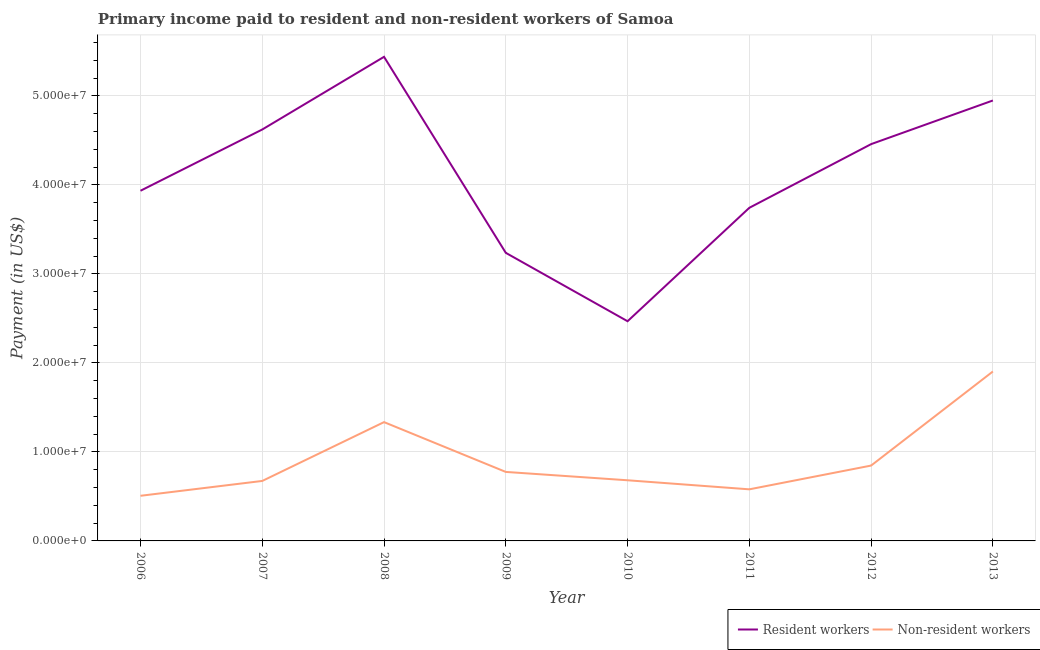What is the payment made to non-resident workers in 2013?
Make the answer very short. 1.90e+07. Across all years, what is the maximum payment made to non-resident workers?
Ensure brevity in your answer.  1.90e+07. Across all years, what is the minimum payment made to resident workers?
Provide a short and direct response. 2.47e+07. What is the total payment made to resident workers in the graph?
Your answer should be very brief. 3.28e+08. What is the difference between the payment made to non-resident workers in 2010 and that in 2012?
Provide a short and direct response. -1.65e+06. What is the difference between the payment made to resident workers in 2007 and the payment made to non-resident workers in 2008?
Your answer should be compact. 3.29e+07. What is the average payment made to resident workers per year?
Provide a succinct answer. 4.11e+07. In the year 2010, what is the difference between the payment made to non-resident workers and payment made to resident workers?
Ensure brevity in your answer.  -1.79e+07. In how many years, is the payment made to resident workers greater than 38000000 US$?
Offer a very short reply. 5. What is the ratio of the payment made to resident workers in 2012 to that in 2013?
Your answer should be very brief. 0.9. Is the difference between the payment made to resident workers in 2006 and 2007 greater than the difference between the payment made to non-resident workers in 2006 and 2007?
Make the answer very short. No. What is the difference between the highest and the second highest payment made to non-resident workers?
Keep it short and to the point. 5.69e+06. What is the difference between the highest and the lowest payment made to resident workers?
Make the answer very short. 2.97e+07. In how many years, is the payment made to resident workers greater than the average payment made to resident workers taken over all years?
Ensure brevity in your answer.  4. Is the sum of the payment made to non-resident workers in 2012 and 2013 greater than the maximum payment made to resident workers across all years?
Your answer should be very brief. No. Is the payment made to non-resident workers strictly greater than the payment made to resident workers over the years?
Offer a very short reply. No. How many years are there in the graph?
Ensure brevity in your answer.  8. What is the difference between two consecutive major ticks on the Y-axis?
Your answer should be very brief. 1.00e+07. Are the values on the major ticks of Y-axis written in scientific E-notation?
Ensure brevity in your answer.  Yes. Does the graph contain any zero values?
Provide a succinct answer. No. Does the graph contain grids?
Offer a terse response. Yes. How many legend labels are there?
Offer a very short reply. 2. What is the title of the graph?
Give a very brief answer. Primary income paid to resident and non-resident workers of Samoa. Does "Commercial service exports" appear as one of the legend labels in the graph?
Provide a succinct answer. No. What is the label or title of the X-axis?
Offer a very short reply. Year. What is the label or title of the Y-axis?
Offer a very short reply. Payment (in US$). What is the Payment (in US$) in Resident workers in 2006?
Provide a short and direct response. 3.93e+07. What is the Payment (in US$) in Non-resident workers in 2006?
Your response must be concise. 5.07e+06. What is the Payment (in US$) of Resident workers in 2007?
Your response must be concise. 4.62e+07. What is the Payment (in US$) of Non-resident workers in 2007?
Make the answer very short. 6.74e+06. What is the Payment (in US$) in Resident workers in 2008?
Give a very brief answer. 5.44e+07. What is the Payment (in US$) in Non-resident workers in 2008?
Offer a very short reply. 1.33e+07. What is the Payment (in US$) of Resident workers in 2009?
Provide a short and direct response. 3.24e+07. What is the Payment (in US$) in Non-resident workers in 2009?
Provide a succinct answer. 7.75e+06. What is the Payment (in US$) of Resident workers in 2010?
Provide a short and direct response. 2.47e+07. What is the Payment (in US$) in Non-resident workers in 2010?
Offer a terse response. 6.81e+06. What is the Payment (in US$) of Resident workers in 2011?
Give a very brief answer. 3.74e+07. What is the Payment (in US$) of Non-resident workers in 2011?
Provide a short and direct response. 5.80e+06. What is the Payment (in US$) in Resident workers in 2012?
Offer a terse response. 4.46e+07. What is the Payment (in US$) of Non-resident workers in 2012?
Your response must be concise. 8.47e+06. What is the Payment (in US$) in Resident workers in 2013?
Offer a very short reply. 4.95e+07. What is the Payment (in US$) in Non-resident workers in 2013?
Your response must be concise. 1.90e+07. Across all years, what is the maximum Payment (in US$) of Resident workers?
Your response must be concise. 5.44e+07. Across all years, what is the maximum Payment (in US$) in Non-resident workers?
Provide a succinct answer. 1.90e+07. Across all years, what is the minimum Payment (in US$) in Resident workers?
Your response must be concise. 2.47e+07. Across all years, what is the minimum Payment (in US$) of Non-resident workers?
Ensure brevity in your answer.  5.07e+06. What is the total Payment (in US$) in Resident workers in the graph?
Your response must be concise. 3.28e+08. What is the total Payment (in US$) of Non-resident workers in the graph?
Make the answer very short. 7.30e+07. What is the difference between the Payment (in US$) of Resident workers in 2006 and that in 2007?
Offer a very short reply. -6.88e+06. What is the difference between the Payment (in US$) in Non-resident workers in 2006 and that in 2007?
Offer a terse response. -1.67e+06. What is the difference between the Payment (in US$) of Resident workers in 2006 and that in 2008?
Offer a very short reply. -1.50e+07. What is the difference between the Payment (in US$) of Non-resident workers in 2006 and that in 2008?
Your response must be concise. -8.28e+06. What is the difference between the Payment (in US$) of Resident workers in 2006 and that in 2009?
Offer a terse response. 6.98e+06. What is the difference between the Payment (in US$) of Non-resident workers in 2006 and that in 2009?
Offer a terse response. -2.68e+06. What is the difference between the Payment (in US$) of Resident workers in 2006 and that in 2010?
Give a very brief answer. 1.47e+07. What is the difference between the Payment (in US$) in Non-resident workers in 2006 and that in 2010?
Give a very brief answer. -1.74e+06. What is the difference between the Payment (in US$) of Resident workers in 2006 and that in 2011?
Give a very brief answer. 1.91e+06. What is the difference between the Payment (in US$) of Non-resident workers in 2006 and that in 2011?
Offer a very short reply. -7.27e+05. What is the difference between the Payment (in US$) of Resident workers in 2006 and that in 2012?
Provide a short and direct response. -5.24e+06. What is the difference between the Payment (in US$) of Non-resident workers in 2006 and that in 2012?
Your answer should be compact. -3.40e+06. What is the difference between the Payment (in US$) of Resident workers in 2006 and that in 2013?
Your answer should be very brief. -1.01e+07. What is the difference between the Payment (in US$) of Non-resident workers in 2006 and that in 2013?
Your answer should be very brief. -1.40e+07. What is the difference between the Payment (in US$) of Resident workers in 2007 and that in 2008?
Make the answer very short. -8.16e+06. What is the difference between the Payment (in US$) in Non-resident workers in 2007 and that in 2008?
Make the answer very short. -6.61e+06. What is the difference between the Payment (in US$) of Resident workers in 2007 and that in 2009?
Offer a very short reply. 1.39e+07. What is the difference between the Payment (in US$) of Non-resident workers in 2007 and that in 2009?
Give a very brief answer. -1.01e+06. What is the difference between the Payment (in US$) of Resident workers in 2007 and that in 2010?
Provide a short and direct response. 2.15e+07. What is the difference between the Payment (in US$) of Non-resident workers in 2007 and that in 2010?
Keep it short and to the point. -7.51e+04. What is the difference between the Payment (in US$) in Resident workers in 2007 and that in 2011?
Offer a very short reply. 8.80e+06. What is the difference between the Payment (in US$) in Non-resident workers in 2007 and that in 2011?
Offer a terse response. 9.42e+05. What is the difference between the Payment (in US$) in Resident workers in 2007 and that in 2012?
Make the answer very short. 1.64e+06. What is the difference between the Payment (in US$) of Non-resident workers in 2007 and that in 2012?
Provide a succinct answer. -1.73e+06. What is the difference between the Payment (in US$) in Resident workers in 2007 and that in 2013?
Your answer should be very brief. -3.26e+06. What is the difference between the Payment (in US$) in Non-resident workers in 2007 and that in 2013?
Your answer should be very brief. -1.23e+07. What is the difference between the Payment (in US$) of Resident workers in 2008 and that in 2009?
Your answer should be very brief. 2.20e+07. What is the difference between the Payment (in US$) in Non-resident workers in 2008 and that in 2009?
Offer a terse response. 5.60e+06. What is the difference between the Payment (in US$) of Resident workers in 2008 and that in 2010?
Give a very brief answer. 2.97e+07. What is the difference between the Payment (in US$) of Non-resident workers in 2008 and that in 2010?
Keep it short and to the point. 6.53e+06. What is the difference between the Payment (in US$) of Resident workers in 2008 and that in 2011?
Give a very brief answer. 1.70e+07. What is the difference between the Payment (in US$) in Non-resident workers in 2008 and that in 2011?
Your response must be concise. 7.55e+06. What is the difference between the Payment (in US$) in Resident workers in 2008 and that in 2012?
Ensure brevity in your answer.  9.81e+06. What is the difference between the Payment (in US$) in Non-resident workers in 2008 and that in 2012?
Ensure brevity in your answer.  4.88e+06. What is the difference between the Payment (in US$) in Resident workers in 2008 and that in 2013?
Keep it short and to the point. 4.91e+06. What is the difference between the Payment (in US$) in Non-resident workers in 2008 and that in 2013?
Give a very brief answer. -5.69e+06. What is the difference between the Payment (in US$) of Resident workers in 2009 and that in 2010?
Your response must be concise. 7.68e+06. What is the difference between the Payment (in US$) in Non-resident workers in 2009 and that in 2010?
Give a very brief answer. 9.38e+05. What is the difference between the Payment (in US$) of Resident workers in 2009 and that in 2011?
Provide a short and direct response. -5.06e+06. What is the difference between the Payment (in US$) in Non-resident workers in 2009 and that in 2011?
Make the answer very short. 1.95e+06. What is the difference between the Payment (in US$) of Resident workers in 2009 and that in 2012?
Offer a very short reply. -1.22e+07. What is the difference between the Payment (in US$) in Non-resident workers in 2009 and that in 2012?
Provide a short and direct response. -7.14e+05. What is the difference between the Payment (in US$) in Resident workers in 2009 and that in 2013?
Your answer should be compact. -1.71e+07. What is the difference between the Payment (in US$) in Non-resident workers in 2009 and that in 2013?
Give a very brief answer. -1.13e+07. What is the difference between the Payment (in US$) in Resident workers in 2010 and that in 2011?
Give a very brief answer. -1.27e+07. What is the difference between the Payment (in US$) of Non-resident workers in 2010 and that in 2011?
Provide a short and direct response. 1.02e+06. What is the difference between the Payment (in US$) of Resident workers in 2010 and that in 2012?
Your response must be concise. -1.99e+07. What is the difference between the Payment (in US$) in Non-resident workers in 2010 and that in 2012?
Your answer should be very brief. -1.65e+06. What is the difference between the Payment (in US$) in Resident workers in 2010 and that in 2013?
Make the answer very short. -2.48e+07. What is the difference between the Payment (in US$) of Non-resident workers in 2010 and that in 2013?
Keep it short and to the point. -1.22e+07. What is the difference between the Payment (in US$) of Resident workers in 2011 and that in 2012?
Keep it short and to the point. -7.15e+06. What is the difference between the Payment (in US$) in Non-resident workers in 2011 and that in 2012?
Keep it short and to the point. -2.67e+06. What is the difference between the Payment (in US$) in Resident workers in 2011 and that in 2013?
Give a very brief answer. -1.21e+07. What is the difference between the Payment (in US$) in Non-resident workers in 2011 and that in 2013?
Your response must be concise. -1.32e+07. What is the difference between the Payment (in US$) in Resident workers in 2012 and that in 2013?
Provide a succinct answer. -4.90e+06. What is the difference between the Payment (in US$) in Non-resident workers in 2012 and that in 2013?
Provide a succinct answer. -1.06e+07. What is the difference between the Payment (in US$) of Resident workers in 2006 and the Payment (in US$) of Non-resident workers in 2007?
Ensure brevity in your answer.  3.26e+07. What is the difference between the Payment (in US$) of Resident workers in 2006 and the Payment (in US$) of Non-resident workers in 2008?
Give a very brief answer. 2.60e+07. What is the difference between the Payment (in US$) in Resident workers in 2006 and the Payment (in US$) in Non-resident workers in 2009?
Offer a very short reply. 3.16e+07. What is the difference between the Payment (in US$) in Resident workers in 2006 and the Payment (in US$) in Non-resident workers in 2010?
Your response must be concise. 3.25e+07. What is the difference between the Payment (in US$) of Resident workers in 2006 and the Payment (in US$) of Non-resident workers in 2011?
Keep it short and to the point. 3.35e+07. What is the difference between the Payment (in US$) in Resident workers in 2006 and the Payment (in US$) in Non-resident workers in 2012?
Offer a terse response. 3.09e+07. What is the difference between the Payment (in US$) in Resident workers in 2006 and the Payment (in US$) in Non-resident workers in 2013?
Your response must be concise. 2.03e+07. What is the difference between the Payment (in US$) of Resident workers in 2007 and the Payment (in US$) of Non-resident workers in 2008?
Give a very brief answer. 3.29e+07. What is the difference between the Payment (in US$) in Resident workers in 2007 and the Payment (in US$) in Non-resident workers in 2009?
Your answer should be compact. 3.85e+07. What is the difference between the Payment (in US$) of Resident workers in 2007 and the Payment (in US$) of Non-resident workers in 2010?
Provide a short and direct response. 3.94e+07. What is the difference between the Payment (in US$) of Resident workers in 2007 and the Payment (in US$) of Non-resident workers in 2011?
Keep it short and to the point. 4.04e+07. What is the difference between the Payment (in US$) in Resident workers in 2007 and the Payment (in US$) in Non-resident workers in 2012?
Keep it short and to the point. 3.78e+07. What is the difference between the Payment (in US$) in Resident workers in 2007 and the Payment (in US$) in Non-resident workers in 2013?
Provide a short and direct response. 2.72e+07. What is the difference between the Payment (in US$) in Resident workers in 2008 and the Payment (in US$) in Non-resident workers in 2009?
Provide a succinct answer. 4.66e+07. What is the difference between the Payment (in US$) in Resident workers in 2008 and the Payment (in US$) in Non-resident workers in 2010?
Your answer should be compact. 4.76e+07. What is the difference between the Payment (in US$) of Resident workers in 2008 and the Payment (in US$) of Non-resident workers in 2011?
Offer a terse response. 4.86e+07. What is the difference between the Payment (in US$) in Resident workers in 2008 and the Payment (in US$) in Non-resident workers in 2012?
Ensure brevity in your answer.  4.59e+07. What is the difference between the Payment (in US$) of Resident workers in 2008 and the Payment (in US$) of Non-resident workers in 2013?
Make the answer very short. 3.53e+07. What is the difference between the Payment (in US$) in Resident workers in 2009 and the Payment (in US$) in Non-resident workers in 2010?
Give a very brief answer. 2.55e+07. What is the difference between the Payment (in US$) in Resident workers in 2009 and the Payment (in US$) in Non-resident workers in 2011?
Give a very brief answer. 2.66e+07. What is the difference between the Payment (in US$) of Resident workers in 2009 and the Payment (in US$) of Non-resident workers in 2012?
Ensure brevity in your answer.  2.39e+07. What is the difference between the Payment (in US$) of Resident workers in 2009 and the Payment (in US$) of Non-resident workers in 2013?
Ensure brevity in your answer.  1.33e+07. What is the difference between the Payment (in US$) of Resident workers in 2010 and the Payment (in US$) of Non-resident workers in 2011?
Provide a succinct answer. 1.89e+07. What is the difference between the Payment (in US$) of Resident workers in 2010 and the Payment (in US$) of Non-resident workers in 2012?
Offer a terse response. 1.62e+07. What is the difference between the Payment (in US$) in Resident workers in 2010 and the Payment (in US$) in Non-resident workers in 2013?
Give a very brief answer. 5.65e+06. What is the difference between the Payment (in US$) of Resident workers in 2011 and the Payment (in US$) of Non-resident workers in 2012?
Your answer should be compact. 2.90e+07. What is the difference between the Payment (in US$) of Resident workers in 2011 and the Payment (in US$) of Non-resident workers in 2013?
Your answer should be very brief. 1.84e+07. What is the difference between the Payment (in US$) in Resident workers in 2012 and the Payment (in US$) in Non-resident workers in 2013?
Offer a terse response. 2.55e+07. What is the average Payment (in US$) of Resident workers per year?
Provide a succinct answer. 4.11e+07. What is the average Payment (in US$) of Non-resident workers per year?
Offer a very short reply. 9.13e+06. In the year 2006, what is the difference between the Payment (in US$) of Resident workers and Payment (in US$) of Non-resident workers?
Provide a short and direct response. 3.43e+07. In the year 2007, what is the difference between the Payment (in US$) in Resident workers and Payment (in US$) in Non-resident workers?
Keep it short and to the point. 3.95e+07. In the year 2008, what is the difference between the Payment (in US$) in Resident workers and Payment (in US$) in Non-resident workers?
Your response must be concise. 4.10e+07. In the year 2009, what is the difference between the Payment (in US$) in Resident workers and Payment (in US$) in Non-resident workers?
Make the answer very short. 2.46e+07. In the year 2010, what is the difference between the Payment (in US$) of Resident workers and Payment (in US$) of Non-resident workers?
Ensure brevity in your answer.  1.79e+07. In the year 2011, what is the difference between the Payment (in US$) of Resident workers and Payment (in US$) of Non-resident workers?
Your answer should be very brief. 3.16e+07. In the year 2012, what is the difference between the Payment (in US$) of Resident workers and Payment (in US$) of Non-resident workers?
Your answer should be compact. 3.61e+07. In the year 2013, what is the difference between the Payment (in US$) of Resident workers and Payment (in US$) of Non-resident workers?
Offer a very short reply. 3.04e+07. What is the ratio of the Payment (in US$) in Resident workers in 2006 to that in 2007?
Provide a succinct answer. 0.85. What is the ratio of the Payment (in US$) in Non-resident workers in 2006 to that in 2007?
Make the answer very short. 0.75. What is the ratio of the Payment (in US$) in Resident workers in 2006 to that in 2008?
Make the answer very short. 0.72. What is the ratio of the Payment (in US$) in Non-resident workers in 2006 to that in 2008?
Keep it short and to the point. 0.38. What is the ratio of the Payment (in US$) of Resident workers in 2006 to that in 2009?
Make the answer very short. 1.22. What is the ratio of the Payment (in US$) of Non-resident workers in 2006 to that in 2009?
Offer a very short reply. 0.65. What is the ratio of the Payment (in US$) in Resident workers in 2006 to that in 2010?
Provide a succinct answer. 1.59. What is the ratio of the Payment (in US$) of Non-resident workers in 2006 to that in 2010?
Keep it short and to the point. 0.74. What is the ratio of the Payment (in US$) of Resident workers in 2006 to that in 2011?
Offer a terse response. 1.05. What is the ratio of the Payment (in US$) of Non-resident workers in 2006 to that in 2011?
Your response must be concise. 0.87. What is the ratio of the Payment (in US$) of Resident workers in 2006 to that in 2012?
Keep it short and to the point. 0.88. What is the ratio of the Payment (in US$) of Non-resident workers in 2006 to that in 2012?
Your answer should be very brief. 0.6. What is the ratio of the Payment (in US$) of Resident workers in 2006 to that in 2013?
Ensure brevity in your answer.  0.8. What is the ratio of the Payment (in US$) of Non-resident workers in 2006 to that in 2013?
Your answer should be compact. 0.27. What is the ratio of the Payment (in US$) of Resident workers in 2007 to that in 2008?
Provide a succinct answer. 0.85. What is the ratio of the Payment (in US$) of Non-resident workers in 2007 to that in 2008?
Provide a short and direct response. 0.5. What is the ratio of the Payment (in US$) in Resident workers in 2007 to that in 2009?
Your response must be concise. 1.43. What is the ratio of the Payment (in US$) in Non-resident workers in 2007 to that in 2009?
Offer a very short reply. 0.87. What is the ratio of the Payment (in US$) in Resident workers in 2007 to that in 2010?
Your answer should be very brief. 1.87. What is the ratio of the Payment (in US$) of Non-resident workers in 2007 to that in 2010?
Give a very brief answer. 0.99. What is the ratio of the Payment (in US$) in Resident workers in 2007 to that in 2011?
Provide a succinct answer. 1.24. What is the ratio of the Payment (in US$) of Non-resident workers in 2007 to that in 2011?
Offer a terse response. 1.16. What is the ratio of the Payment (in US$) of Resident workers in 2007 to that in 2012?
Ensure brevity in your answer.  1.04. What is the ratio of the Payment (in US$) of Non-resident workers in 2007 to that in 2012?
Your response must be concise. 0.8. What is the ratio of the Payment (in US$) in Resident workers in 2007 to that in 2013?
Ensure brevity in your answer.  0.93. What is the ratio of the Payment (in US$) in Non-resident workers in 2007 to that in 2013?
Offer a very short reply. 0.35. What is the ratio of the Payment (in US$) in Resident workers in 2008 to that in 2009?
Provide a short and direct response. 1.68. What is the ratio of the Payment (in US$) in Non-resident workers in 2008 to that in 2009?
Keep it short and to the point. 1.72. What is the ratio of the Payment (in US$) in Resident workers in 2008 to that in 2010?
Provide a succinct answer. 2.2. What is the ratio of the Payment (in US$) of Non-resident workers in 2008 to that in 2010?
Provide a succinct answer. 1.96. What is the ratio of the Payment (in US$) of Resident workers in 2008 to that in 2011?
Your response must be concise. 1.45. What is the ratio of the Payment (in US$) in Non-resident workers in 2008 to that in 2011?
Provide a succinct answer. 2.3. What is the ratio of the Payment (in US$) in Resident workers in 2008 to that in 2012?
Provide a succinct answer. 1.22. What is the ratio of the Payment (in US$) in Non-resident workers in 2008 to that in 2012?
Give a very brief answer. 1.58. What is the ratio of the Payment (in US$) in Resident workers in 2008 to that in 2013?
Offer a terse response. 1.1. What is the ratio of the Payment (in US$) in Non-resident workers in 2008 to that in 2013?
Ensure brevity in your answer.  0.7. What is the ratio of the Payment (in US$) in Resident workers in 2009 to that in 2010?
Your response must be concise. 1.31. What is the ratio of the Payment (in US$) in Non-resident workers in 2009 to that in 2010?
Your response must be concise. 1.14. What is the ratio of the Payment (in US$) of Resident workers in 2009 to that in 2011?
Give a very brief answer. 0.86. What is the ratio of the Payment (in US$) in Non-resident workers in 2009 to that in 2011?
Your answer should be very brief. 1.34. What is the ratio of the Payment (in US$) of Resident workers in 2009 to that in 2012?
Keep it short and to the point. 0.73. What is the ratio of the Payment (in US$) of Non-resident workers in 2009 to that in 2012?
Your answer should be very brief. 0.92. What is the ratio of the Payment (in US$) of Resident workers in 2009 to that in 2013?
Keep it short and to the point. 0.65. What is the ratio of the Payment (in US$) of Non-resident workers in 2009 to that in 2013?
Keep it short and to the point. 0.41. What is the ratio of the Payment (in US$) in Resident workers in 2010 to that in 2011?
Your answer should be very brief. 0.66. What is the ratio of the Payment (in US$) in Non-resident workers in 2010 to that in 2011?
Give a very brief answer. 1.18. What is the ratio of the Payment (in US$) of Resident workers in 2010 to that in 2012?
Your answer should be compact. 0.55. What is the ratio of the Payment (in US$) in Non-resident workers in 2010 to that in 2012?
Keep it short and to the point. 0.8. What is the ratio of the Payment (in US$) of Resident workers in 2010 to that in 2013?
Provide a short and direct response. 0.5. What is the ratio of the Payment (in US$) of Non-resident workers in 2010 to that in 2013?
Your answer should be very brief. 0.36. What is the ratio of the Payment (in US$) of Resident workers in 2011 to that in 2012?
Offer a terse response. 0.84. What is the ratio of the Payment (in US$) of Non-resident workers in 2011 to that in 2012?
Your answer should be compact. 0.68. What is the ratio of the Payment (in US$) of Resident workers in 2011 to that in 2013?
Your answer should be compact. 0.76. What is the ratio of the Payment (in US$) in Non-resident workers in 2011 to that in 2013?
Provide a short and direct response. 0.3. What is the ratio of the Payment (in US$) in Resident workers in 2012 to that in 2013?
Make the answer very short. 0.9. What is the ratio of the Payment (in US$) in Non-resident workers in 2012 to that in 2013?
Provide a succinct answer. 0.44. What is the difference between the highest and the second highest Payment (in US$) of Resident workers?
Give a very brief answer. 4.91e+06. What is the difference between the highest and the second highest Payment (in US$) in Non-resident workers?
Offer a very short reply. 5.69e+06. What is the difference between the highest and the lowest Payment (in US$) in Resident workers?
Keep it short and to the point. 2.97e+07. What is the difference between the highest and the lowest Payment (in US$) in Non-resident workers?
Ensure brevity in your answer.  1.40e+07. 